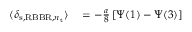Convert formula to latex. <formula><loc_0><loc_0><loc_500><loc_500>\begin{array} { r l } { \langle \delta _ { s , R B B R , n _ { t } } \rangle } & = - \frac { a } { 8 } \left [ \Psi ( 1 ) - \Psi ( 3 ) \right ] } \end{array}</formula> 